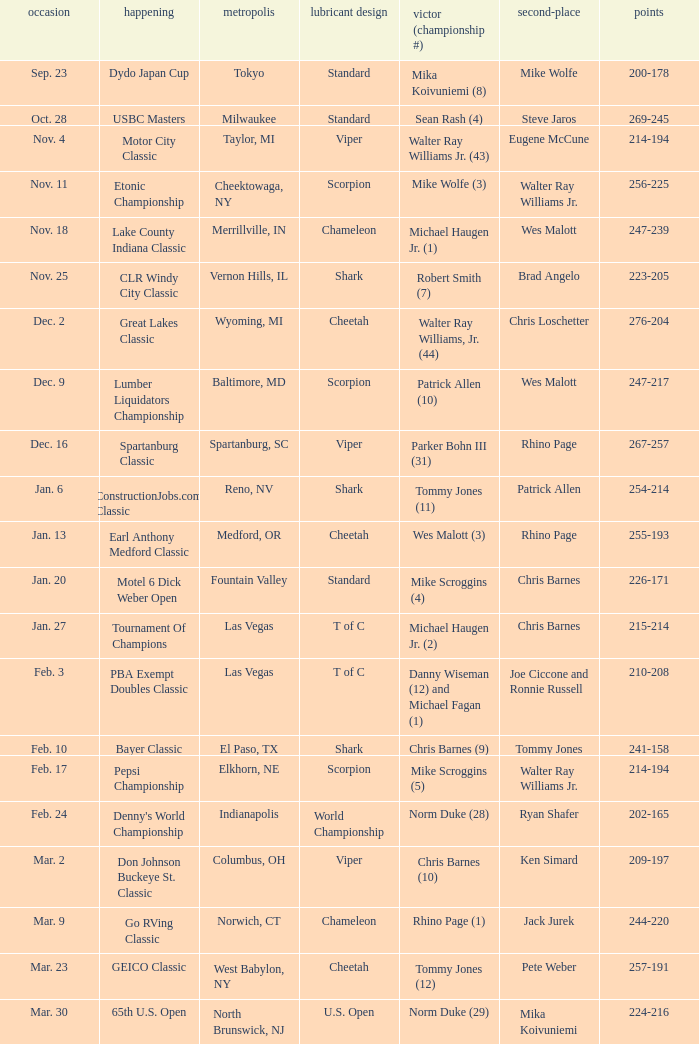Which Score has an Event of constructionjobs.com classic? 254-214. Would you mind parsing the complete table? {'header': ['occasion', 'happening', 'metropolis', 'lubricant design', 'victor (championship #)', 'second-place', 'points'], 'rows': [['Sep. 23', 'Dydo Japan Cup', 'Tokyo', 'Standard', 'Mika Koivuniemi (8)', 'Mike Wolfe', '200-178'], ['Oct. 28', 'USBC Masters', 'Milwaukee', 'Standard', 'Sean Rash (4)', 'Steve Jaros', '269-245'], ['Nov. 4', 'Motor City Classic', 'Taylor, MI', 'Viper', 'Walter Ray Williams Jr. (43)', 'Eugene McCune', '214-194'], ['Nov. 11', 'Etonic Championship', 'Cheektowaga, NY', 'Scorpion', 'Mike Wolfe (3)', 'Walter Ray Williams Jr.', '256-225'], ['Nov. 18', 'Lake County Indiana Classic', 'Merrillville, IN', 'Chameleon', 'Michael Haugen Jr. (1)', 'Wes Malott', '247-239'], ['Nov. 25', 'CLR Windy City Classic', 'Vernon Hills, IL', 'Shark', 'Robert Smith (7)', 'Brad Angelo', '223-205'], ['Dec. 2', 'Great Lakes Classic', 'Wyoming, MI', 'Cheetah', 'Walter Ray Williams, Jr. (44)', 'Chris Loschetter', '276-204'], ['Dec. 9', 'Lumber Liquidators Championship', 'Baltimore, MD', 'Scorpion', 'Patrick Allen (10)', 'Wes Malott', '247-217'], ['Dec. 16', 'Spartanburg Classic', 'Spartanburg, SC', 'Viper', 'Parker Bohn III (31)', 'Rhino Page', '267-257'], ['Jan. 6', 'ConstructionJobs.com Classic', 'Reno, NV', 'Shark', 'Tommy Jones (11)', 'Patrick Allen', '254-214'], ['Jan. 13', 'Earl Anthony Medford Classic', 'Medford, OR', 'Cheetah', 'Wes Malott (3)', 'Rhino Page', '255-193'], ['Jan. 20', 'Motel 6 Dick Weber Open', 'Fountain Valley', 'Standard', 'Mike Scroggins (4)', 'Chris Barnes', '226-171'], ['Jan. 27', 'Tournament Of Champions', 'Las Vegas', 'T of C', 'Michael Haugen Jr. (2)', 'Chris Barnes', '215-214'], ['Feb. 3', 'PBA Exempt Doubles Classic', 'Las Vegas', 'T of C', 'Danny Wiseman (12) and Michael Fagan (1)', 'Joe Ciccone and Ronnie Russell', '210-208'], ['Feb. 10', 'Bayer Classic', 'El Paso, TX', 'Shark', 'Chris Barnes (9)', 'Tommy Jones', '241-158'], ['Feb. 17', 'Pepsi Championship', 'Elkhorn, NE', 'Scorpion', 'Mike Scroggins (5)', 'Walter Ray Williams Jr.', '214-194'], ['Feb. 24', "Denny's World Championship", 'Indianapolis', 'World Championship', 'Norm Duke (28)', 'Ryan Shafer', '202-165'], ['Mar. 2', 'Don Johnson Buckeye St. Classic', 'Columbus, OH', 'Viper', 'Chris Barnes (10)', 'Ken Simard', '209-197'], ['Mar. 9', 'Go RVing Classic', 'Norwich, CT', 'Chameleon', 'Rhino Page (1)', 'Jack Jurek', '244-220'], ['Mar. 23', 'GEICO Classic', 'West Babylon, NY', 'Cheetah', 'Tommy Jones (12)', 'Pete Weber', '257-191'], ['Mar. 30', '65th U.S. Open', 'North Brunswick, NJ', 'U.S. Open', 'Norm Duke (29)', 'Mika Koivuniemi', '224-216']]} 